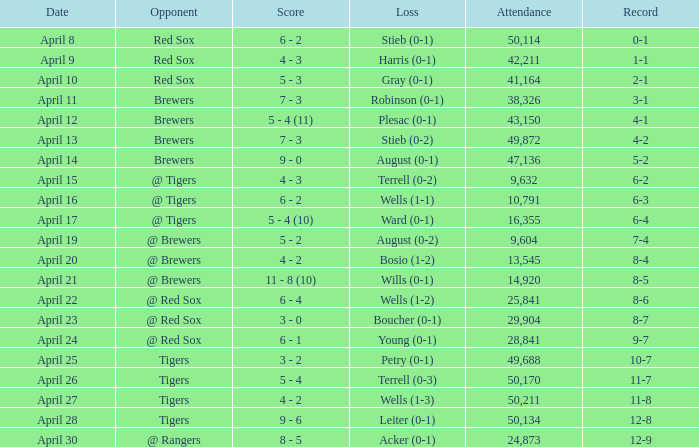What is the largest attendance that has tigers as the opponent and a loss of leiter (0-1)? 50134.0. 